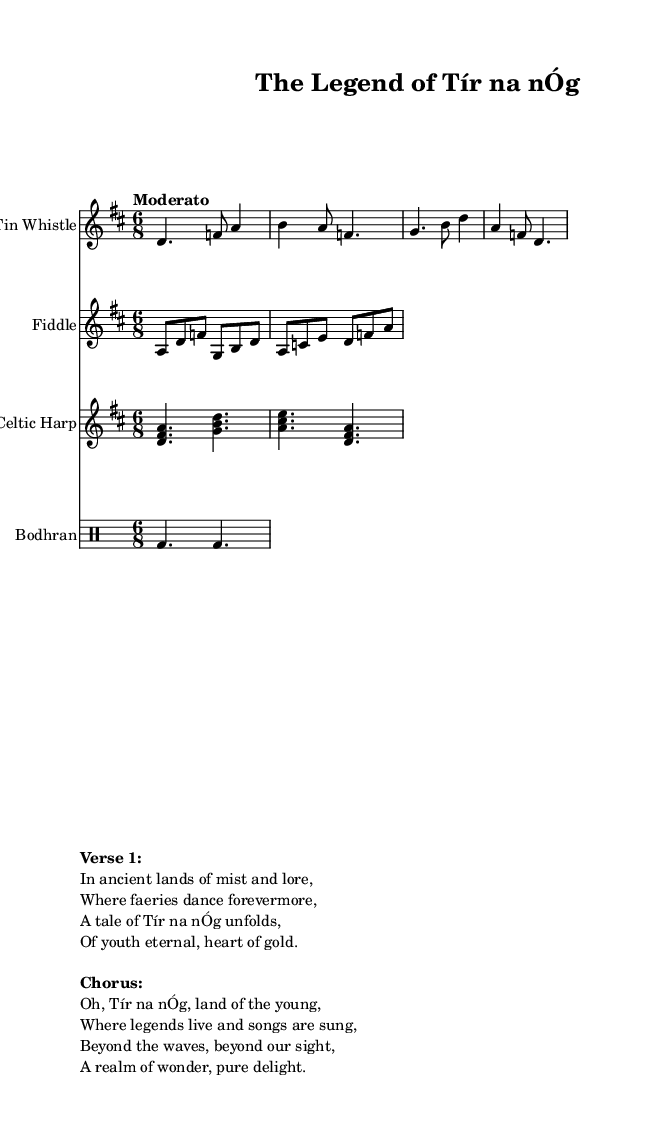What is the key signature of this music? The key signature indicated is D major, which has two sharps (F# and C#). This can be identified at the beginning of the score where the key signature is shown or from the context of the notes used.
Answer: D major What is the time signature of this music? The time signature is 6/8, which can be seen at the beginning of the score. This means there are six eighth notes in each measure, which is common for folk music and contributes to its dance-like feel.
Answer: 6/8 What is the indicated tempo of this piece? The tempo marking is "Moderato," which is found in the global section of the score. This term indicates a moderate speed, typically around 108-120 beats per minute in music.
Answer: Moderato What instruments are included in this score? The instruments listed in the score are Tin Whistle, Fiddle, Celtic Harp, and Bodhran. Each instrument has its own staff with labeled instrument names at the beginning of each line.
Answer: Tin Whistle, Fiddle, Celtic Harp, Bodhran What theme does the text of the song primarily focus on? The lyrics describe a legendary place called Tír na nÓg, which ties into themes of eternal youth and folklore. This is reflected in both the title and the verses presented in the markup.
Answer: Ancient legends and folklore How does the structure of the music reflect traditional Celtic styles? The combination of a moderate tempo, the use of 6/8 time signature, and the inclusion of instruments like the Tin Whistle and Bodhran all align with traditional Celtic music characteristics, as these elements create a dance-like rhythm typical in Celtic folk music.
Answer: Traditional Celtic What does the name "Tír na nÓg" symbolize in this musical piece? "Tír na nÓg" translates to "Land of the Young," which alludes to the folk theme of an idyllic place where beauty and youth are eternal. This legendary paradise serves as a central theme in Irish mythology.
Answer: Eternal youth 